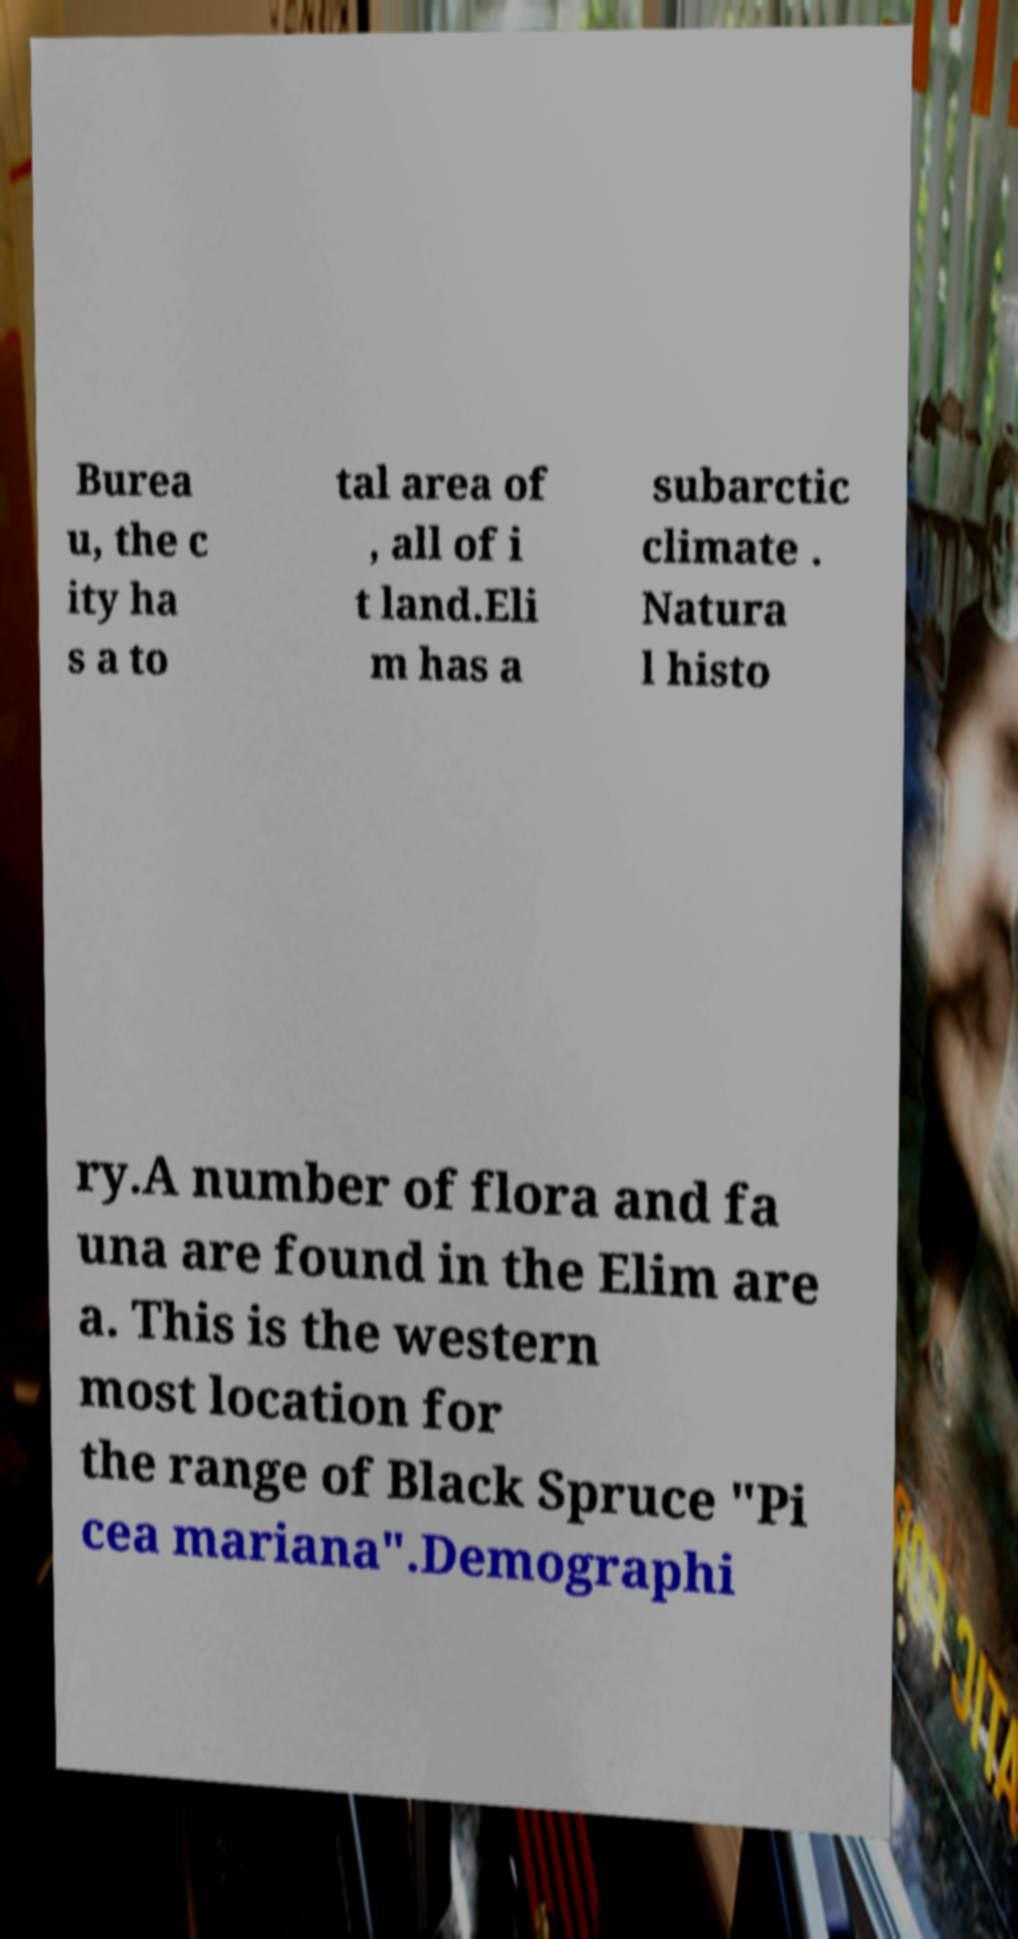Could you assist in decoding the text presented in this image and type it out clearly? Burea u, the c ity ha s a to tal area of , all of i t land.Eli m has a subarctic climate . Natura l histo ry.A number of flora and fa una are found in the Elim are a. This is the western most location for the range of Black Spruce "Pi cea mariana".Demographi 